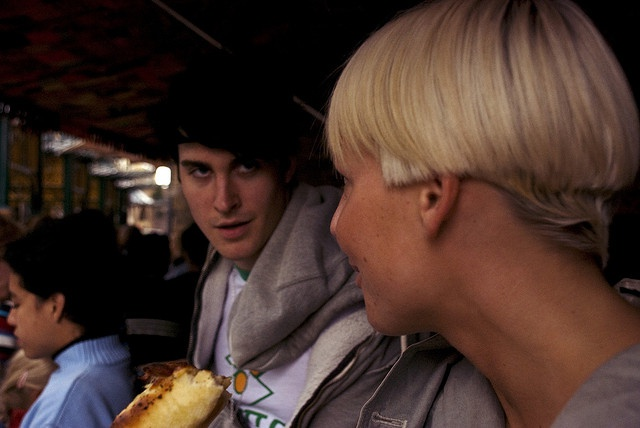Describe the objects in this image and their specific colors. I can see people in black, maroon, gray, and brown tones, people in black, gray, maroon, and darkgray tones, people in black, maroon, gray, and darkgray tones, sandwich in black, tan, brown, and maroon tones, and people in black, maroon, and brown tones in this image. 